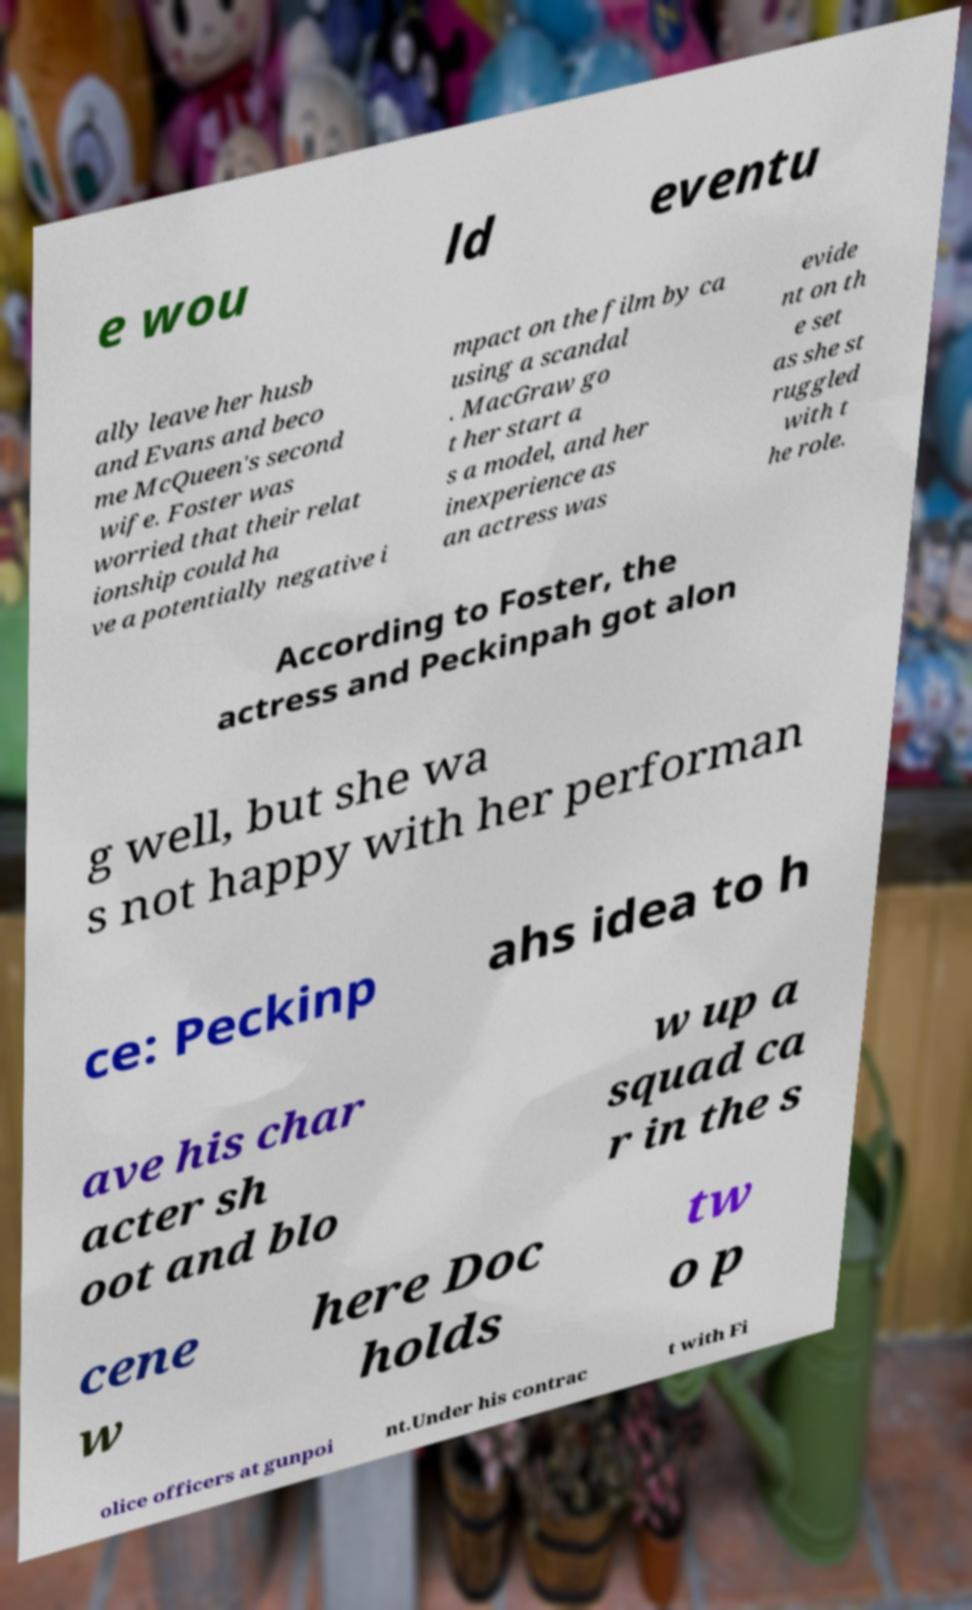Could you assist in decoding the text presented in this image and type it out clearly? e wou ld eventu ally leave her husb and Evans and beco me McQueen's second wife. Foster was worried that their relat ionship could ha ve a potentially negative i mpact on the film by ca using a scandal . MacGraw go t her start a s a model, and her inexperience as an actress was evide nt on th e set as she st ruggled with t he role. According to Foster, the actress and Peckinpah got alon g well, but she wa s not happy with her performan ce: Peckinp ahs idea to h ave his char acter sh oot and blo w up a squad ca r in the s cene w here Doc holds tw o p olice officers at gunpoi nt.Under his contrac t with Fi 